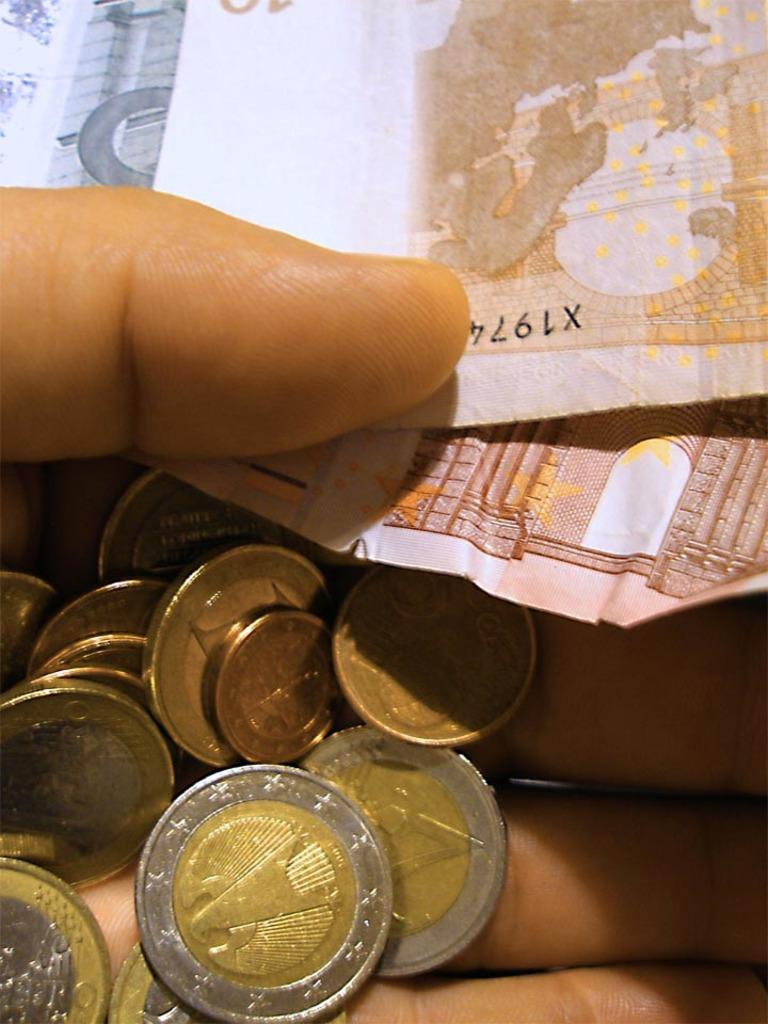<image>
Render a clear and concise summary of the photo. a hand holding a bunch of coins and some paper money, one has X1974 on it 